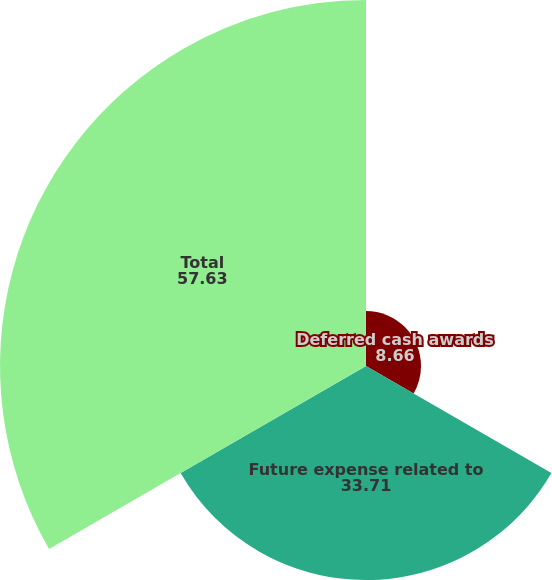Convert chart. <chart><loc_0><loc_0><loc_500><loc_500><pie_chart><fcel>Deferred cash awards<fcel>Future expense related to<fcel>Total<nl><fcel>8.66%<fcel>33.71%<fcel>57.63%<nl></chart> 